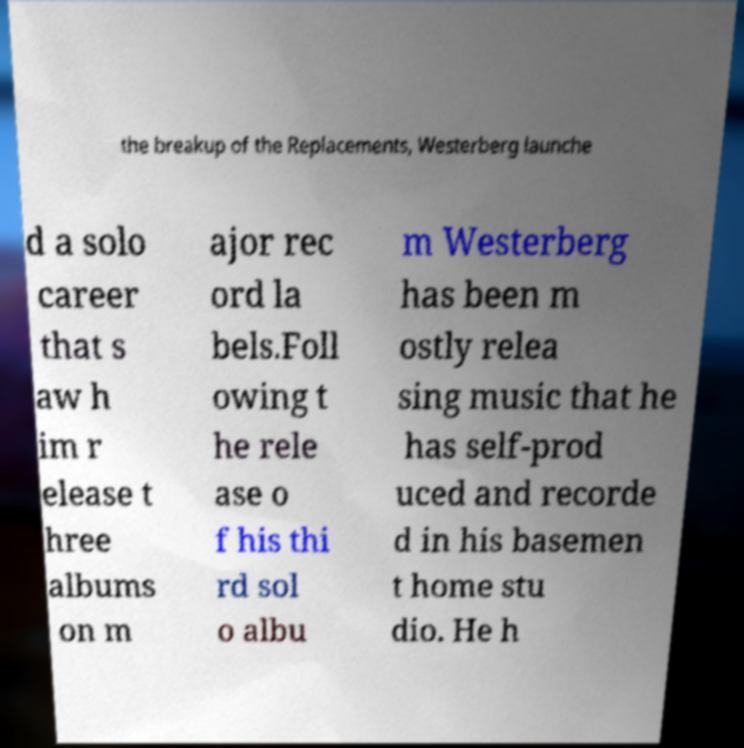Can you read and provide the text displayed in the image?This photo seems to have some interesting text. Can you extract and type it out for me? the breakup of the Replacements, Westerberg launche d a solo career that s aw h im r elease t hree albums on m ajor rec ord la bels.Foll owing t he rele ase o f his thi rd sol o albu m Westerberg has been m ostly relea sing music that he has self-prod uced and recorde d in his basemen t home stu dio. He h 